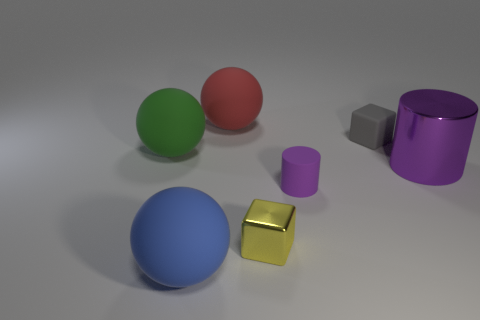There is a small thing that is the same color as the shiny cylinder; what material is it?
Make the answer very short. Rubber. Do the matte cylinder and the big metal cylinder have the same color?
Provide a succinct answer. Yes. There is a purple cylinder to the right of the tiny purple rubber object; what material is it?
Offer a very short reply. Metal. What is the size of the yellow metal object?
Keep it short and to the point. Small. What number of yellow things are either large things or small shiny cubes?
Offer a terse response. 1. What size is the thing that is in front of the shiny thing in front of the purple shiny thing?
Offer a very short reply. Large. There is a large cylinder; is it the same color as the small matte object that is in front of the green rubber ball?
Offer a very short reply. Yes. What number of other things are there of the same material as the big cylinder
Ensure brevity in your answer.  1. What is the shape of the green thing that is the same material as the tiny purple thing?
Make the answer very short. Sphere. Is there anything else that is the same color as the tiny cylinder?
Provide a succinct answer. Yes. 